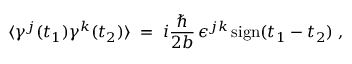Convert formula to latex. <formula><loc_0><loc_0><loc_500><loc_500>\langle \gamma ^ { j } ( t _ { 1 } ) \gamma ^ { k } ( t _ { 2 } ) \rangle \, = \, i \frac { } { 2 b } \, \epsilon ^ { j k } \, s i g n ( t _ { 1 } - t _ { 2 } ) \, ,</formula> 